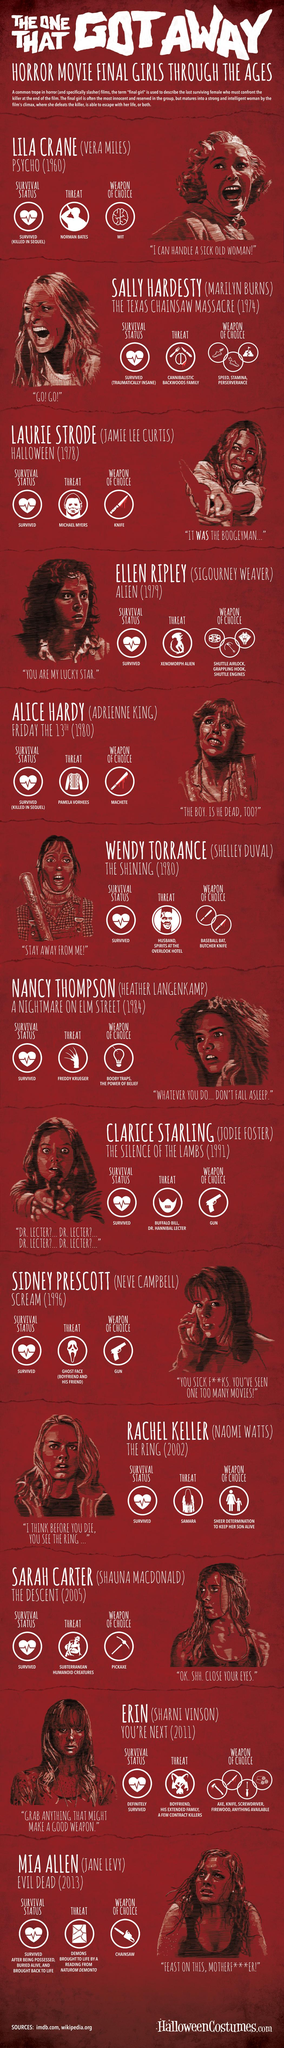Indicate a few pertinent items in this graphic. The threat to Sally Hardesty was from a cannibalistic backwoods family. Norman Bates plays a significant role as a threat in the novel Psycho. Vera Miles played the lead role in the psychological thriller film Psycho, which was directed by Alfred Hitchcock. Michael Myers was the antagonist in Halloween. It is reported that two individuals, who were at high risk of being killed, were able to escape a murder due to circumstances that allowed them to evade danger. 